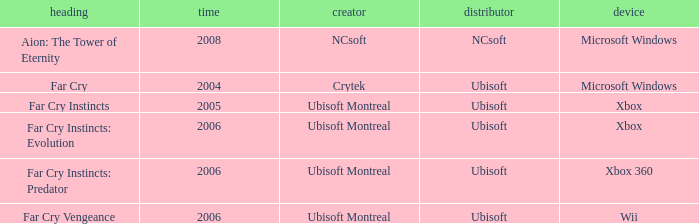Which developer has xbox 360 as the platform? Ubisoft Montreal. 